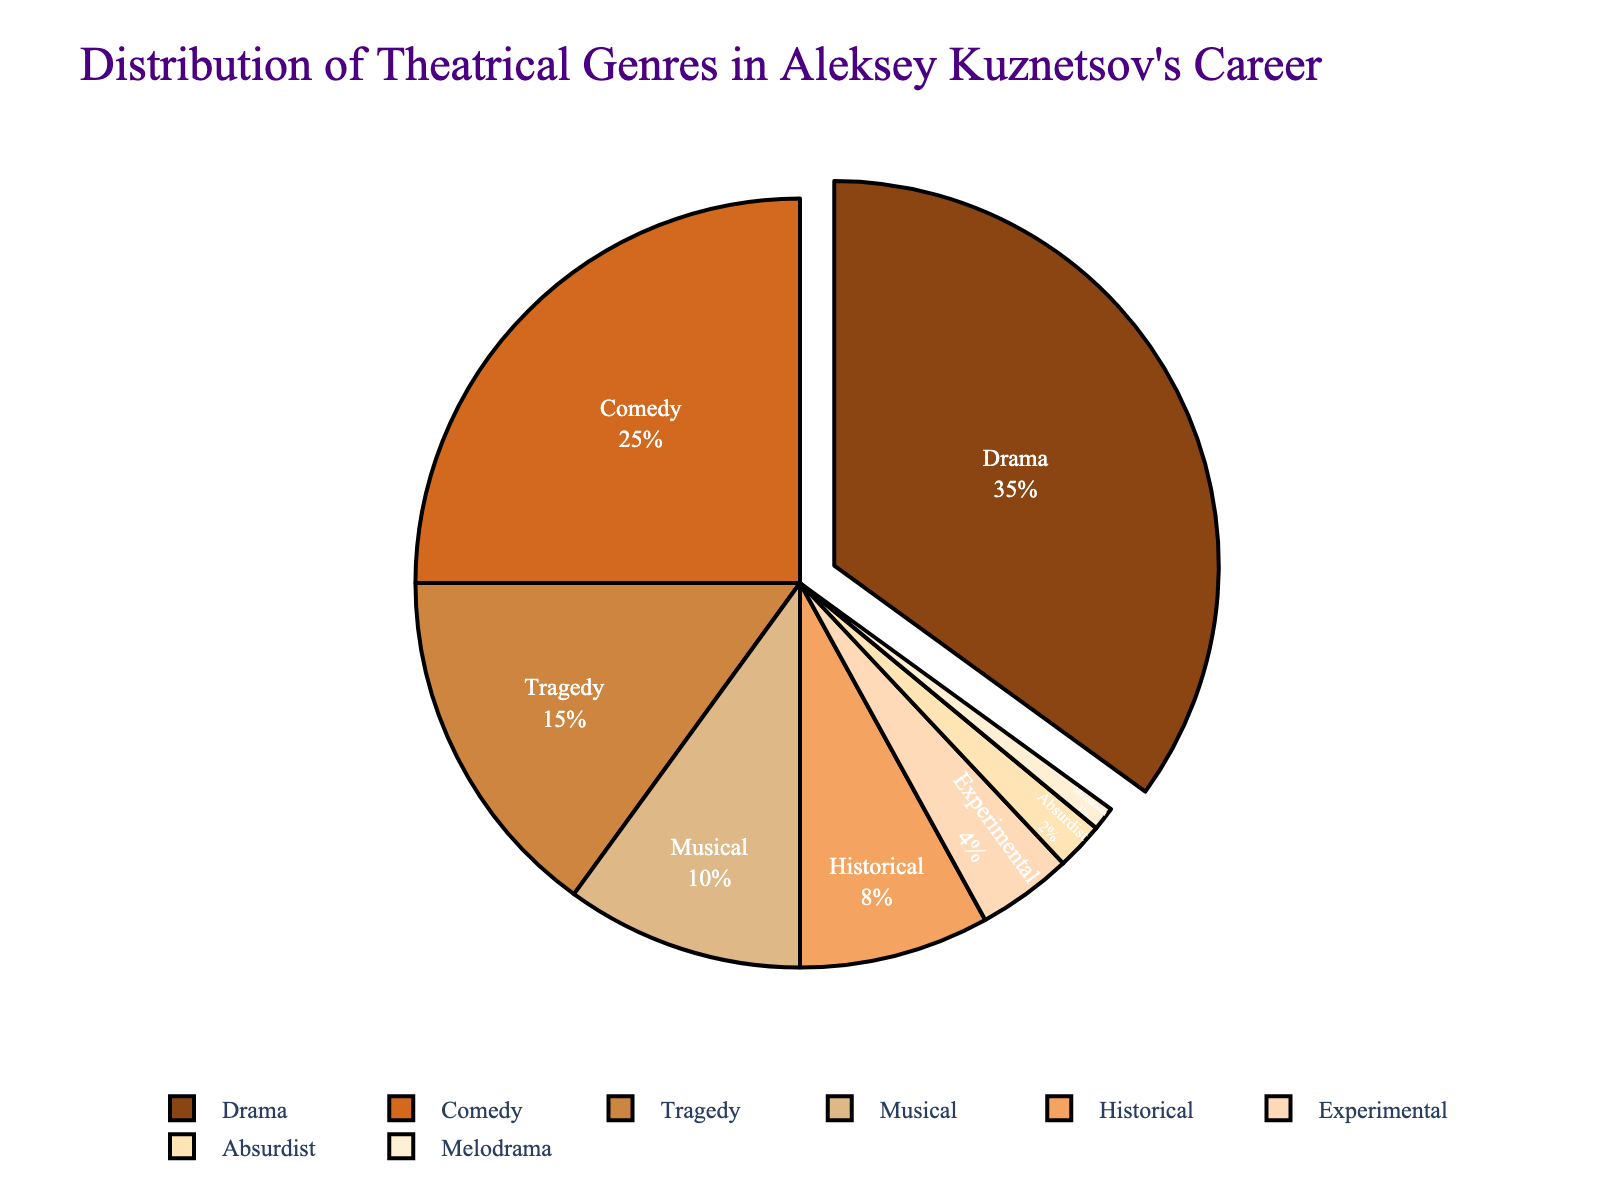what genre makes up the largest percentage of Aleksey Kuznetsov's performances? The largest segment of the pie chart represents Drama, which makes up 35% of Aleksey Kuznetsov's performances.
Answer: Drama Which two genres together make up 50% of Aleksey Kuznetsov's performances? The percentages of Drama and Comedy are 35% and 25% respectively. Adding these together, we get 35% + 25% = 60%, which exceeds 50%. However, if we consider succeeding genres, Drama (35%) and Tragedy (15%) together make up exactly 50%.
Answer: Drama and Tragedy Compare the combined percentage of Musical and Historical genres with the percentage of Comedy. Which is greater? The percentages for Musical and Historical are 10% and 8% respectively, adding up to 18%. The percentage for Comedy alone is 25%. Since 25% > 18%, the percentage of Comedy is greater.
Answer: Comedy By how much does the percentage of Drama performances exceed that of Musicals? The percentage of Drama performances is 35%, and the percentage of Musicals is 10%. The difference is calculated as 35% - 10% = 25%.
Answer: 25% What percentage of performances fall under genres with single-digit percentages? The genres with single-digit percentages are Historical (8%), Experimental (4%), Absurdist (2%), and Melodrama (1%). Adding these: 8% + 4% + 2% + 1% = 15%.
Answer: 15% What is the color associated with the genre that has the smallest percentage in the pie chart? The genre with the smallest percentage is Melodrama (1%). In the pie chart, Melodrama is represented by a pale yellow color.
Answer: Pale yellow Is the combined percentage of Absurdist and Melodrama performances greater than the percentage of Experimental performances? The percentages of Absurdist and Melodrama are 2% and 1% respectively, adding to 3%. The percentage of Experimental performance is 4%. Since 3% < 4%, the combined percentage of Absurdist and Melodrama performances is not greater than Experimental.
Answer: No How many genres have a percentage greater than 10% in Aleksey Kuznetsov's performances? By observing the percentage labels on the pie chart, the genres with more than 10% are Drama (35%), Comedy (25%), and Tragedy (15%). There are thus three genres.
Answer: 3 Which genre has a slightly lower percentage compared to Historical, and how much is the difference? Experimental has a slightly lower percentage compared to Historical. Historical's percentage is 8%, and Experimental's is 4%. The difference is 8% - 4% = 4%.
Answer: Experimental by 4% 